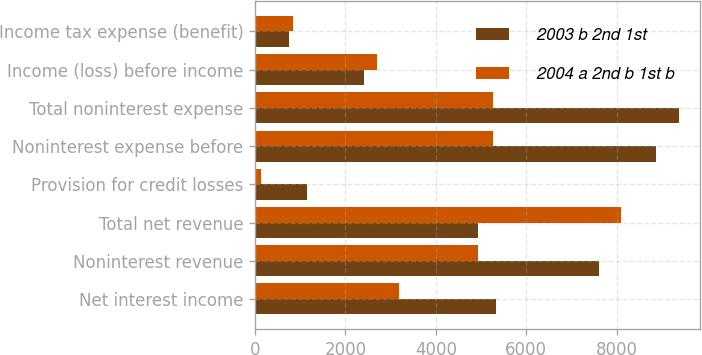Convert chart to OTSL. <chart><loc_0><loc_0><loc_500><loc_500><stacked_bar_chart><ecel><fcel>Net interest income<fcel>Noninterest revenue<fcel>Total net revenue<fcel>Provision for credit losses<fcel>Noninterest expense before<fcel>Total noninterest expense<fcel>Income (loss) before income<fcel>Income tax expense (benefit)<nl><fcel>2003 b 2nd 1st<fcel>5329<fcel>7621<fcel>4924<fcel>1157<fcel>8863<fcel>9386<fcel>2407<fcel>741<nl><fcel>2004 a 2nd b 1st b<fcel>3182<fcel>4924<fcel>8106<fcel>139<fcel>5258<fcel>5258<fcel>2709<fcel>845<nl></chart> 